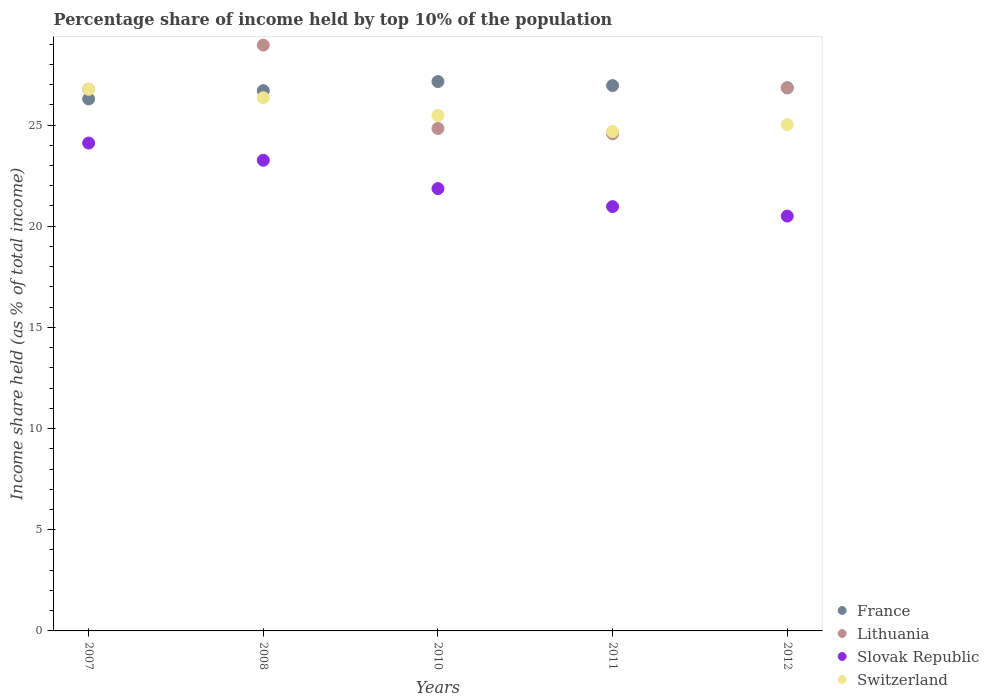How many different coloured dotlines are there?
Provide a succinct answer. 4. What is the percentage share of income held by top 10% of the population in Lithuania in 2011?
Ensure brevity in your answer.  24.57. Across all years, what is the maximum percentage share of income held by top 10% of the population in France?
Provide a short and direct response. 27.15. In which year was the percentage share of income held by top 10% of the population in Lithuania minimum?
Give a very brief answer. 2011. What is the total percentage share of income held by top 10% of the population in Slovak Republic in the graph?
Provide a short and direct response. 110.7. What is the difference between the percentage share of income held by top 10% of the population in Switzerland in 2010 and that in 2012?
Ensure brevity in your answer.  0.45. What is the difference between the percentage share of income held by top 10% of the population in Lithuania in 2012 and the percentage share of income held by top 10% of the population in Slovak Republic in 2008?
Offer a very short reply. 3.58. What is the average percentage share of income held by top 10% of the population in Lithuania per year?
Keep it short and to the point. 26.39. In the year 2007, what is the difference between the percentage share of income held by top 10% of the population in Lithuania and percentage share of income held by top 10% of the population in Slovak Republic?
Your answer should be compact. 2.66. In how many years, is the percentage share of income held by top 10% of the population in Slovak Republic greater than 3 %?
Your response must be concise. 5. What is the ratio of the percentage share of income held by top 10% of the population in Switzerland in 2011 to that in 2012?
Your answer should be very brief. 0.99. What is the difference between the highest and the second highest percentage share of income held by top 10% of the population in Slovak Republic?
Ensure brevity in your answer.  0.85. What is the difference between the highest and the lowest percentage share of income held by top 10% of the population in Slovak Republic?
Provide a succinct answer. 3.61. In how many years, is the percentage share of income held by top 10% of the population in France greater than the average percentage share of income held by top 10% of the population in France taken over all years?
Provide a succinct answer. 3. Is the sum of the percentage share of income held by top 10% of the population in Switzerland in 2007 and 2012 greater than the maximum percentage share of income held by top 10% of the population in Slovak Republic across all years?
Your answer should be compact. Yes. Is it the case that in every year, the sum of the percentage share of income held by top 10% of the population in Slovak Republic and percentage share of income held by top 10% of the population in Lithuania  is greater than the percentage share of income held by top 10% of the population in Switzerland?
Keep it short and to the point. Yes. Are the values on the major ticks of Y-axis written in scientific E-notation?
Offer a terse response. No. Where does the legend appear in the graph?
Give a very brief answer. Bottom right. What is the title of the graph?
Your answer should be very brief. Percentage share of income held by top 10% of the population. What is the label or title of the X-axis?
Your response must be concise. Years. What is the label or title of the Y-axis?
Offer a terse response. Income share held (as % of total income). What is the Income share held (as % of total income) in France in 2007?
Offer a terse response. 26.29. What is the Income share held (as % of total income) of Lithuania in 2007?
Offer a terse response. 26.77. What is the Income share held (as % of total income) in Slovak Republic in 2007?
Your answer should be very brief. 24.11. What is the Income share held (as % of total income) in Switzerland in 2007?
Your answer should be compact. 26.77. What is the Income share held (as % of total income) of France in 2008?
Provide a succinct answer. 26.7. What is the Income share held (as % of total income) of Lithuania in 2008?
Your response must be concise. 28.95. What is the Income share held (as % of total income) in Slovak Republic in 2008?
Offer a very short reply. 23.26. What is the Income share held (as % of total income) in Switzerland in 2008?
Ensure brevity in your answer.  26.35. What is the Income share held (as % of total income) in France in 2010?
Make the answer very short. 27.15. What is the Income share held (as % of total income) of Lithuania in 2010?
Provide a short and direct response. 24.83. What is the Income share held (as % of total income) of Slovak Republic in 2010?
Ensure brevity in your answer.  21.86. What is the Income share held (as % of total income) of Switzerland in 2010?
Ensure brevity in your answer.  25.47. What is the Income share held (as % of total income) in France in 2011?
Ensure brevity in your answer.  26.95. What is the Income share held (as % of total income) in Lithuania in 2011?
Your response must be concise. 24.57. What is the Income share held (as % of total income) of Slovak Republic in 2011?
Give a very brief answer. 20.97. What is the Income share held (as % of total income) of Switzerland in 2011?
Give a very brief answer. 24.68. What is the Income share held (as % of total income) in France in 2012?
Provide a short and direct response. 26.84. What is the Income share held (as % of total income) of Lithuania in 2012?
Ensure brevity in your answer.  26.84. What is the Income share held (as % of total income) in Switzerland in 2012?
Offer a very short reply. 25.02. Across all years, what is the maximum Income share held (as % of total income) in France?
Provide a short and direct response. 27.15. Across all years, what is the maximum Income share held (as % of total income) of Lithuania?
Make the answer very short. 28.95. Across all years, what is the maximum Income share held (as % of total income) of Slovak Republic?
Keep it short and to the point. 24.11. Across all years, what is the maximum Income share held (as % of total income) of Switzerland?
Your answer should be compact. 26.77. Across all years, what is the minimum Income share held (as % of total income) of France?
Provide a short and direct response. 26.29. Across all years, what is the minimum Income share held (as % of total income) in Lithuania?
Provide a succinct answer. 24.57. Across all years, what is the minimum Income share held (as % of total income) of Slovak Republic?
Your answer should be compact. 20.5. Across all years, what is the minimum Income share held (as % of total income) of Switzerland?
Provide a short and direct response. 24.68. What is the total Income share held (as % of total income) of France in the graph?
Offer a very short reply. 133.93. What is the total Income share held (as % of total income) in Lithuania in the graph?
Your response must be concise. 131.96. What is the total Income share held (as % of total income) in Slovak Republic in the graph?
Make the answer very short. 110.7. What is the total Income share held (as % of total income) of Switzerland in the graph?
Offer a very short reply. 128.29. What is the difference between the Income share held (as % of total income) of France in 2007 and that in 2008?
Give a very brief answer. -0.41. What is the difference between the Income share held (as % of total income) of Lithuania in 2007 and that in 2008?
Your response must be concise. -2.18. What is the difference between the Income share held (as % of total income) in Switzerland in 2007 and that in 2008?
Your response must be concise. 0.42. What is the difference between the Income share held (as % of total income) of France in 2007 and that in 2010?
Your answer should be compact. -0.86. What is the difference between the Income share held (as % of total income) of Lithuania in 2007 and that in 2010?
Your answer should be compact. 1.94. What is the difference between the Income share held (as % of total income) in Slovak Republic in 2007 and that in 2010?
Your answer should be compact. 2.25. What is the difference between the Income share held (as % of total income) of Switzerland in 2007 and that in 2010?
Make the answer very short. 1.3. What is the difference between the Income share held (as % of total income) of France in 2007 and that in 2011?
Keep it short and to the point. -0.66. What is the difference between the Income share held (as % of total income) of Lithuania in 2007 and that in 2011?
Provide a succinct answer. 2.2. What is the difference between the Income share held (as % of total income) in Slovak Republic in 2007 and that in 2011?
Offer a very short reply. 3.14. What is the difference between the Income share held (as % of total income) of Switzerland in 2007 and that in 2011?
Ensure brevity in your answer.  2.09. What is the difference between the Income share held (as % of total income) in France in 2007 and that in 2012?
Offer a very short reply. -0.55. What is the difference between the Income share held (as % of total income) in Lithuania in 2007 and that in 2012?
Provide a succinct answer. -0.07. What is the difference between the Income share held (as % of total income) of Slovak Republic in 2007 and that in 2012?
Your answer should be very brief. 3.61. What is the difference between the Income share held (as % of total income) in Switzerland in 2007 and that in 2012?
Offer a very short reply. 1.75. What is the difference between the Income share held (as % of total income) of France in 2008 and that in 2010?
Your response must be concise. -0.45. What is the difference between the Income share held (as % of total income) of Lithuania in 2008 and that in 2010?
Provide a short and direct response. 4.12. What is the difference between the Income share held (as % of total income) of Switzerland in 2008 and that in 2010?
Give a very brief answer. 0.88. What is the difference between the Income share held (as % of total income) of Lithuania in 2008 and that in 2011?
Offer a terse response. 4.38. What is the difference between the Income share held (as % of total income) in Slovak Republic in 2008 and that in 2011?
Your answer should be very brief. 2.29. What is the difference between the Income share held (as % of total income) in Switzerland in 2008 and that in 2011?
Offer a terse response. 1.67. What is the difference between the Income share held (as % of total income) in France in 2008 and that in 2012?
Keep it short and to the point. -0.14. What is the difference between the Income share held (as % of total income) in Lithuania in 2008 and that in 2012?
Offer a very short reply. 2.11. What is the difference between the Income share held (as % of total income) of Slovak Republic in 2008 and that in 2012?
Offer a terse response. 2.76. What is the difference between the Income share held (as % of total income) of Switzerland in 2008 and that in 2012?
Your answer should be compact. 1.33. What is the difference between the Income share held (as % of total income) of France in 2010 and that in 2011?
Give a very brief answer. 0.2. What is the difference between the Income share held (as % of total income) in Lithuania in 2010 and that in 2011?
Your answer should be very brief. 0.26. What is the difference between the Income share held (as % of total income) of Slovak Republic in 2010 and that in 2011?
Give a very brief answer. 0.89. What is the difference between the Income share held (as % of total income) of Switzerland in 2010 and that in 2011?
Offer a very short reply. 0.79. What is the difference between the Income share held (as % of total income) of France in 2010 and that in 2012?
Provide a succinct answer. 0.31. What is the difference between the Income share held (as % of total income) of Lithuania in 2010 and that in 2012?
Provide a succinct answer. -2.01. What is the difference between the Income share held (as % of total income) of Slovak Republic in 2010 and that in 2012?
Your response must be concise. 1.36. What is the difference between the Income share held (as % of total income) of Switzerland in 2010 and that in 2012?
Provide a succinct answer. 0.45. What is the difference between the Income share held (as % of total income) in France in 2011 and that in 2012?
Your answer should be very brief. 0.11. What is the difference between the Income share held (as % of total income) of Lithuania in 2011 and that in 2012?
Keep it short and to the point. -2.27. What is the difference between the Income share held (as % of total income) of Slovak Republic in 2011 and that in 2012?
Provide a succinct answer. 0.47. What is the difference between the Income share held (as % of total income) of Switzerland in 2011 and that in 2012?
Make the answer very short. -0.34. What is the difference between the Income share held (as % of total income) in France in 2007 and the Income share held (as % of total income) in Lithuania in 2008?
Offer a terse response. -2.66. What is the difference between the Income share held (as % of total income) of France in 2007 and the Income share held (as % of total income) of Slovak Republic in 2008?
Offer a very short reply. 3.03. What is the difference between the Income share held (as % of total income) in France in 2007 and the Income share held (as % of total income) in Switzerland in 2008?
Give a very brief answer. -0.06. What is the difference between the Income share held (as % of total income) in Lithuania in 2007 and the Income share held (as % of total income) in Slovak Republic in 2008?
Your answer should be very brief. 3.51. What is the difference between the Income share held (as % of total income) of Lithuania in 2007 and the Income share held (as % of total income) of Switzerland in 2008?
Give a very brief answer. 0.42. What is the difference between the Income share held (as % of total income) of Slovak Republic in 2007 and the Income share held (as % of total income) of Switzerland in 2008?
Provide a succinct answer. -2.24. What is the difference between the Income share held (as % of total income) in France in 2007 and the Income share held (as % of total income) in Lithuania in 2010?
Offer a terse response. 1.46. What is the difference between the Income share held (as % of total income) in France in 2007 and the Income share held (as % of total income) in Slovak Republic in 2010?
Your answer should be very brief. 4.43. What is the difference between the Income share held (as % of total income) in France in 2007 and the Income share held (as % of total income) in Switzerland in 2010?
Your answer should be compact. 0.82. What is the difference between the Income share held (as % of total income) of Lithuania in 2007 and the Income share held (as % of total income) of Slovak Republic in 2010?
Make the answer very short. 4.91. What is the difference between the Income share held (as % of total income) in Lithuania in 2007 and the Income share held (as % of total income) in Switzerland in 2010?
Your answer should be compact. 1.3. What is the difference between the Income share held (as % of total income) in Slovak Republic in 2007 and the Income share held (as % of total income) in Switzerland in 2010?
Keep it short and to the point. -1.36. What is the difference between the Income share held (as % of total income) in France in 2007 and the Income share held (as % of total income) in Lithuania in 2011?
Provide a short and direct response. 1.72. What is the difference between the Income share held (as % of total income) in France in 2007 and the Income share held (as % of total income) in Slovak Republic in 2011?
Your response must be concise. 5.32. What is the difference between the Income share held (as % of total income) in France in 2007 and the Income share held (as % of total income) in Switzerland in 2011?
Your answer should be very brief. 1.61. What is the difference between the Income share held (as % of total income) in Lithuania in 2007 and the Income share held (as % of total income) in Switzerland in 2011?
Give a very brief answer. 2.09. What is the difference between the Income share held (as % of total income) in Slovak Republic in 2007 and the Income share held (as % of total income) in Switzerland in 2011?
Give a very brief answer. -0.57. What is the difference between the Income share held (as % of total income) of France in 2007 and the Income share held (as % of total income) of Lithuania in 2012?
Ensure brevity in your answer.  -0.55. What is the difference between the Income share held (as % of total income) of France in 2007 and the Income share held (as % of total income) of Slovak Republic in 2012?
Offer a terse response. 5.79. What is the difference between the Income share held (as % of total income) in France in 2007 and the Income share held (as % of total income) in Switzerland in 2012?
Make the answer very short. 1.27. What is the difference between the Income share held (as % of total income) in Lithuania in 2007 and the Income share held (as % of total income) in Slovak Republic in 2012?
Your answer should be compact. 6.27. What is the difference between the Income share held (as % of total income) in Slovak Republic in 2007 and the Income share held (as % of total income) in Switzerland in 2012?
Offer a terse response. -0.91. What is the difference between the Income share held (as % of total income) of France in 2008 and the Income share held (as % of total income) of Lithuania in 2010?
Your answer should be very brief. 1.87. What is the difference between the Income share held (as % of total income) in France in 2008 and the Income share held (as % of total income) in Slovak Republic in 2010?
Provide a short and direct response. 4.84. What is the difference between the Income share held (as % of total income) in France in 2008 and the Income share held (as % of total income) in Switzerland in 2010?
Provide a succinct answer. 1.23. What is the difference between the Income share held (as % of total income) in Lithuania in 2008 and the Income share held (as % of total income) in Slovak Republic in 2010?
Your response must be concise. 7.09. What is the difference between the Income share held (as % of total income) in Lithuania in 2008 and the Income share held (as % of total income) in Switzerland in 2010?
Give a very brief answer. 3.48. What is the difference between the Income share held (as % of total income) of Slovak Republic in 2008 and the Income share held (as % of total income) of Switzerland in 2010?
Offer a very short reply. -2.21. What is the difference between the Income share held (as % of total income) in France in 2008 and the Income share held (as % of total income) in Lithuania in 2011?
Provide a succinct answer. 2.13. What is the difference between the Income share held (as % of total income) of France in 2008 and the Income share held (as % of total income) of Slovak Republic in 2011?
Provide a succinct answer. 5.73. What is the difference between the Income share held (as % of total income) in France in 2008 and the Income share held (as % of total income) in Switzerland in 2011?
Your answer should be compact. 2.02. What is the difference between the Income share held (as % of total income) in Lithuania in 2008 and the Income share held (as % of total income) in Slovak Republic in 2011?
Give a very brief answer. 7.98. What is the difference between the Income share held (as % of total income) of Lithuania in 2008 and the Income share held (as % of total income) of Switzerland in 2011?
Offer a very short reply. 4.27. What is the difference between the Income share held (as % of total income) of Slovak Republic in 2008 and the Income share held (as % of total income) of Switzerland in 2011?
Your answer should be compact. -1.42. What is the difference between the Income share held (as % of total income) of France in 2008 and the Income share held (as % of total income) of Lithuania in 2012?
Your answer should be compact. -0.14. What is the difference between the Income share held (as % of total income) in France in 2008 and the Income share held (as % of total income) in Switzerland in 2012?
Your response must be concise. 1.68. What is the difference between the Income share held (as % of total income) in Lithuania in 2008 and the Income share held (as % of total income) in Slovak Republic in 2012?
Give a very brief answer. 8.45. What is the difference between the Income share held (as % of total income) in Lithuania in 2008 and the Income share held (as % of total income) in Switzerland in 2012?
Offer a terse response. 3.93. What is the difference between the Income share held (as % of total income) in Slovak Republic in 2008 and the Income share held (as % of total income) in Switzerland in 2012?
Ensure brevity in your answer.  -1.76. What is the difference between the Income share held (as % of total income) in France in 2010 and the Income share held (as % of total income) in Lithuania in 2011?
Provide a succinct answer. 2.58. What is the difference between the Income share held (as % of total income) in France in 2010 and the Income share held (as % of total income) in Slovak Republic in 2011?
Offer a terse response. 6.18. What is the difference between the Income share held (as % of total income) in France in 2010 and the Income share held (as % of total income) in Switzerland in 2011?
Offer a very short reply. 2.47. What is the difference between the Income share held (as % of total income) in Lithuania in 2010 and the Income share held (as % of total income) in Slovak Republic in 2011?
Your answer should be very brief. 3.86. What is the difference between the Income share held (as % of total income) in Lithuania in 2010 and the Income share held (as % of total income) in Switzerland in 2011?
Ensure brevity in your answer.  0.15. What is the difference between the Income share held (as % of total income) in Slovak Republic in 2010 and the Income share held (as % of total income) in Switzerland in 2011?
Offer a terse response. -2.82. What is the difference between the Income share held (as % of total income) in France in 2010 and the Income share held (as % of total income) in Lithuania in 2012?
Make the answer very short. 0.31. What is the difference between the Income share held (as % of total income) of France in 2010 and the Income share held (as % of total income) of Slovak Republic in 2012?
Make the answer very short. 6.65. What is the difference between the Income share held (as % of total income) of France in 2010 and the Income share held (as % of total income) of Switzerland in 2012?
Ensure brevity in your answer.  2.13. What is the difference between the Income share held (as % of total income) of Lithuania in 2010 and the Income share held (as % of total income) of Slovak Republic in 2012?
Provide a succinct answer. 4.33. What is the difference between the Income share held (as % of total income) of Lithuania in 2010 and the Income share held (as % of total income) of Switzerland in 2012?
Make the answer very short. -0.19. What is the difference between the Income share held (as % of total income) of Slovak Republic in 2010 and the Income share held (as % of total income) of Switzerland in 2012?
Keep it short and to the point. -3.16. What is the difference between the Income share held (as % of total income) in France in 2011 and the Income share held (as % of total income) in Lithuania in 2012?
Offer a terse response. 0.11. What is the difference between the Income share held (as % of total income) in France in 2011 and the Income share held (as % of total income) in Slovak Republic in 2012?
Offer a very short reply. 6.45. What is the difference between the Income share held (as % of total income) in France in 2011 and the Income share held (as % of total income) in Switzerland in 2012?
Your answer should be compact. 1.93. What is the difference between the Income share held (as % of total income) of Lithuania in 2011 and the Income share held (as % of total income) of Slovak Republic in 2012?
Ensure brevity in your answer.  4.07. What is the difference between the Income share held (as % of total income) in Lithuania in 2011 and the Income share held (as % of total income) in Switzerland in 2012?
Give a very brief answer. -0.45. What is the difference between the Income share held (as % of total income) of Slovak Republic in 2011 and the Income share held (as % of total income) of Switzerland in 2012?
Give a very brief answer. -4.05. What is the average Income share held (as % of total income) in France per year?
Provide a short and direct response. 26.79. What is the average Income share held (as % of total income) in Lithuania per year?
Keep it short and to the point. 26.39. What is the average Income share held (as % of total income) in Slovak Republic per year?
Provide a succinct answer. 22.14. What is the average Income share held (as % of total income) in Switzerland per year?
Provide a short and direct response. 25.66. In the year 2007, what is the difference between the Income share held (as % of total income) of France and Income share held (as % of total income) of Lithuania?
Make the answer very short. -0.48. In the year 2007, what is the difference between the Income share held (as % of total income) in France and Income share held (as % of total income) in Slovak Republic?
Give a very brief answer. 2.18. In the year 2007, what is the difference between the Income share held (as % of total income) of France and Income share held (as % of total income) of Switzerland?
Ensure brevity in your answer.  -0.48. In the year 2007, what is the difference between the Income share held (as % of total income) in Lithuania and Income share held (as % of total income) in Slovak Republic?
Your answer should be compact. 2.66. In the year 2007, what is the difference between the Income share held (as % of total income) in Lithuania and Income share held (as % of total income) in Switzerland?
Your answer should be compact. 0. In the year 2007, what is the difference between the Income share held (as % of total income) in Slovak Republic and Income share held (as % of total income) in Switzerland?
Your answer should be very brief. -2.66. In the year 2008, what is the difference between the Income share held (as % of total income) in France and Income share held (as % of total income) in Lithuania?
Keep it short and to the point. -2.25. In the year 2008, what is the difference between the Income share held (as % of total income) of France and Income share held (as % of total income) of Slovak Republic?
Offer a very short reply. 3.44. In the year 2008, what is the difference between the Income share held (as % of total income) in Lithuania and Income share held (as % of total income) in Slovak Republic?
Give a very brief answer. 5.69. In the year 2008, what is the difference between the Income share held (as % of total income) in Lithuania and Income share held (as % of total income) in Switzerland?
Provide a short and direct response. 2.6. In the year 2008, what is the difference between the Income share held (as % of total income) in Slovak Republic and Income share held (as % of total income) in Switzerland?
Your response must be concise. -3.09. In the year 2010, what is the difference between the Income share held (as % of total income) in France and Income share held (as % of total income) in Lithuania?
Make the answer very short. 2.32. In the year 2010, what is the difference between the Income share held (as % of total income) of France and Income share held (as % of total income) of Slovak Republic?
Provide a short and direct response. 5.29. In the year 2010, what is the difference between the Income share held (as % of total income) of France and Income share held (as % of total income) of Switzerland?
Make the answer very short. 1.68. In the year 2010, what is the difference between the Income share held (as % of total income) in Lithuania and Income share held (as % of total income) in Slovak Republic?
Give a very brief answer. 2.97. In the year 2010, what is the difference between the Income share held (as % of total income) in Lithuania and Income share held (as % of total income) in Switzerland?
Provide a succinct answer. -0.64. In the year 2010, what is the difference between the Income share held (as % of total income) in Slovak Republic and Income share held (as % of total income) in Switzerland?
Offer a terse response. -3.61. In the year 2011, what is the difference between the Income share held (as % of total income) in France and Income share held (as % of total income) in Lithuania?
Your answer should be compact. 2.38. In the year 2011, what is the difference between the Income share held (as % of total income) in France and Income share held (as % of total income) in Slovak Republic?
Offer a very short reply. 5.98. In the year 2011, what is the difference between the Income share held (as % of total income) in France and Income share held (as % of total income) in Switzerland?
Ensure brevity in your answer.  2.27. In the year 2011, what is the difference between the Income share held (as % of total income) of Lithuania and Income share held (as % of total income) of Switzerland?
Ensure brevity in your answer.  -0.11. In the year 2011, what is the difference between the Income share held (as % of total income) of Slovak Republic and Income share held (as % of total income) of Switzerland?
Provide a succinct answer. -3.71. In the year 2012, what is the difference between the Income share held (as % of total income) of France and Income share held (as % of total income) of Slovak Republic?
Ensure brevity in your answer.  6.34. In the year 2012, what is the difference between the Income share held (as % of total income) of France and Income share held (as % of total income) of Switzerland?
Provide a succinct answer. 1.82. In the year 2012, what is the difference between the Income share held (as % of total income) in Lithuania and Income share held (as % of total income) in Slovak Republic?
Make the answer very short. 6.34. In the year 2012, what is the difference between the Income share held (as % of total income) of Lithuania and Income share held (as % of total income) of Switzerland?
Give a very brief answer. 1.82. In the year 2012, what is the difference between the Income share held (as % of total income) of Slovak Republic and Income share held (as % of total income) of Switzerland?
Provide a short and direct response. -4.52. What is the ratio of the Income share held (as % of total income) of France in 2007 to that in 2008?
Offer a terse response. 0.98. What is the ratio of the Income share held (as % of total income) of Lithuania in 2007 to that in 2008?
Provide a short and direct response. 0.92. What is the ratio of the Income share held (as % of total income) in Slovak Republic in 2007 to that in 2008?
Your answer should be compact. 1.04. What is the ratio of the Income share held (as % of total income) of Switzerland in 2007 to that in 2008?
Keep it short and to the point. 1.02. What is the ratio of the Income share held (as % of total income) of France in 2007 to that in 2010?
Your answer should be very brief. 0.97. What is the ratio of the Income share held (as % of total income) of Lithuania in 2007 to that in 2010?
Your answer should be compact. 1.08. What is the ratio of the Income share held (as % of total income) of Slovak Republic in 2007 to that in 2010?
Keep it short and to the point. 1.1. What is the ratio of the Income share held (as % of total income) of Switzerland in 2007 to that in 2010?
Your answer should be very brief. 1.05. What is the ratio of the Income share held (as % of total income) of France in 2007 to that in 2011?
Your answer should be compact. 0.98. What is the ratio of the Income share held (as % of total income) in Lithuania in 2007 to that in 2011?
Provide a succinct answer. 1.09. What is the ratio of the Income share held (as % of total income) of Slovak Republic in 2007 to that in 2011?
Your response must be concise. 1.15. What is the ratio of the Income share held (as % of total income) of Switzerland in 2007 to that in 2011?
Provide a succinct answer. 1.08. What is the ratio of the Income share held (as % of total income) in France in 2007 to that in 2012?
Offer a terse response. 0.98. What is the ratio of the Income share held (as % of total income) of Slovak Republic in 2007 to that in 2012?
Provide a short and direct response. 1.18. What is the ratio of the Income share held (as % of total income) in Switzerland in 2007 to that in 2012?
Provide a succinct answer. 1.07. What is the ratio of the Income share held (as % of total income) in France in 2008 to that in 2010?
Keep it short and to the point. 0.98. What is the ratio of the Income share held (as % of total income) of Lithuania in 2008 to that in 2010?
Keep it short and to the point. 1.17. What is the ratio of the Income share held (as % of total income) of Slovak Republic in 2008 to that in 2010?
Make the answer very short. 1.06. What is the ratio of the Income share held (as % of total income) of Switzerland in 2008 to that in 2010?
Your answer should be compact. 1.03. What is the ratio of the Income share held (as % of total income) of Lithuania in 2008 to that in 2011?
Your response must be concise. 1.18. What is the ratio of the Income share held (as % of total income) in Slovak Republic in 2008 to that in 2011?
Make the answer very short. 1.11. What is the ratio of the Income share held (as % of total income) of Switzerland in 2008 to that in 2011?
Ensure brevity in your answer.  1.07. What is the ratio of the Income share held (as % of total income) in France in 2008 to that in 2012?
Offer a terse response. 0.99. What is the ratio of the Income share held (as % of total income) of Lithuania in 2008 to that in 2012?
Provide a short and direct response. 1.08. What is the ratio of the Income share held (as % of total income) of Slovak Republic in 2008 to that in 2012?
Offer a terse response. 1.13. What is the ratio of the Income share held (as % of total income) in Switzerland in 2008 to that in 2012?
Provide a succinct answer. 1.05. What is the ratio of the Income share held (as % of total income) in France in 2010 to that in 2011?
Your response must be concise. 1.01. What is the ratio of the Income share held (as % of total income) in Lithuania in 2010 to that in 2011?
Offer a very short reply. 1.01. What is the ratio of the Income share held (as % of total income) of Slovak Republic in 2010 to that in 2011?
Make the answer very short. 1.04. What is the ratio of the Income share held (as % of total income) of Switzerland in 2010 to that in 2011?
Provide a succinct answer. 1.03. What is the ratio of the Income share held (as % of total income) of France in 2010 to that in 2012?
Your response must be concise. 1.01. What is the ratio of the Income share held (as % of total income) of Lithuania in 2010 to that in 2012?
Provide a succinct answer. 0.93. What is the ratio of the Income share held (as % of total income) of Slovak Republic in 2010 to that in 2012?
Your answer should be very brief. 1.07. What is the ratio of the Income share held (as % of total income) in France in 2011 to that in 2012?
Give a very brief answer. 1. What is the ratio of the Income share held (as % of total income) of Lithuania in 2011 to that in 2012?
Give a very brief answer. 0.92. What is the ratio of the Income share held (as % of total income) of Slovak Republic in 2011 to that in 2012?
Offer a terse response. 1.02. What is the ratio of the Income share held (as % of total income) in Switzerland in 2011 to that in 2012?
Offer a terse response. 0.99. What is the difference between the highest and the second highest Income share held (as % of total income) of Lithuania?
Offer a terse response. 2.11. What is the difference between the highest and the second highest Income share held (as % of total income) in Switzerland?
Offer a terse response. 0.42. What is the difference between the highest and the lowest Income share held (as % of total income) of France?
Your answer should be very brief. 0.86. What is the difference between the highest and the lowest Income share held (as % of total income) of Lithuania?
Your answer should be compact. 4.38. What is the difference between the highest and the lowest Income share held (as % of total income) of Slovak Republic?
Your answer should be compact. 3.61. What is the difference between the highest and the lowest Income share held (as % of total income) of Switzerland?
Make the answer very short. 2.09. 